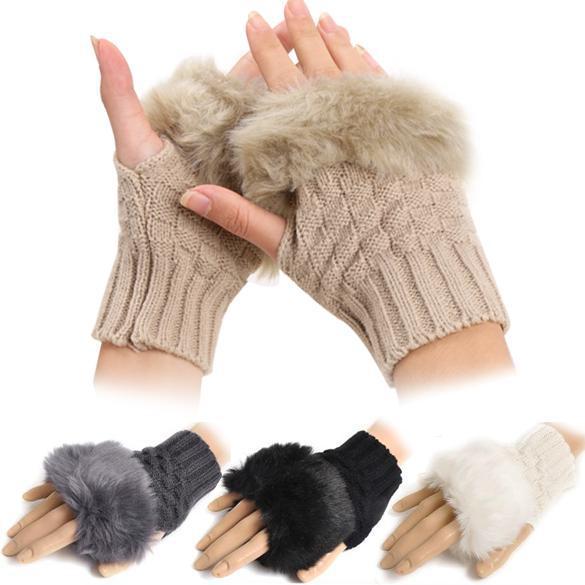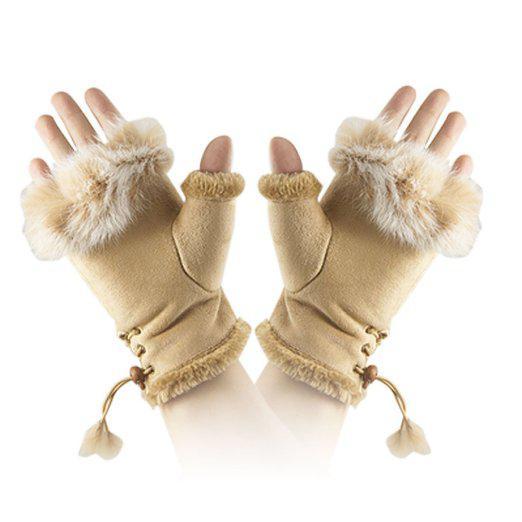The first image is the image on the left, the second image is the image on the right. Examine the images to the left and right. Is the description "One image shows human hands wearing gloves, and one shows a pair of unworn gloves." accurate? Answer yes or no. No. The first image is the image on the left, the second image is the image on the right. Assess this claim about the two images: "A dark brown pair of gloves are worn by a human hand.". Correct or not? Answer yes or no. No. 